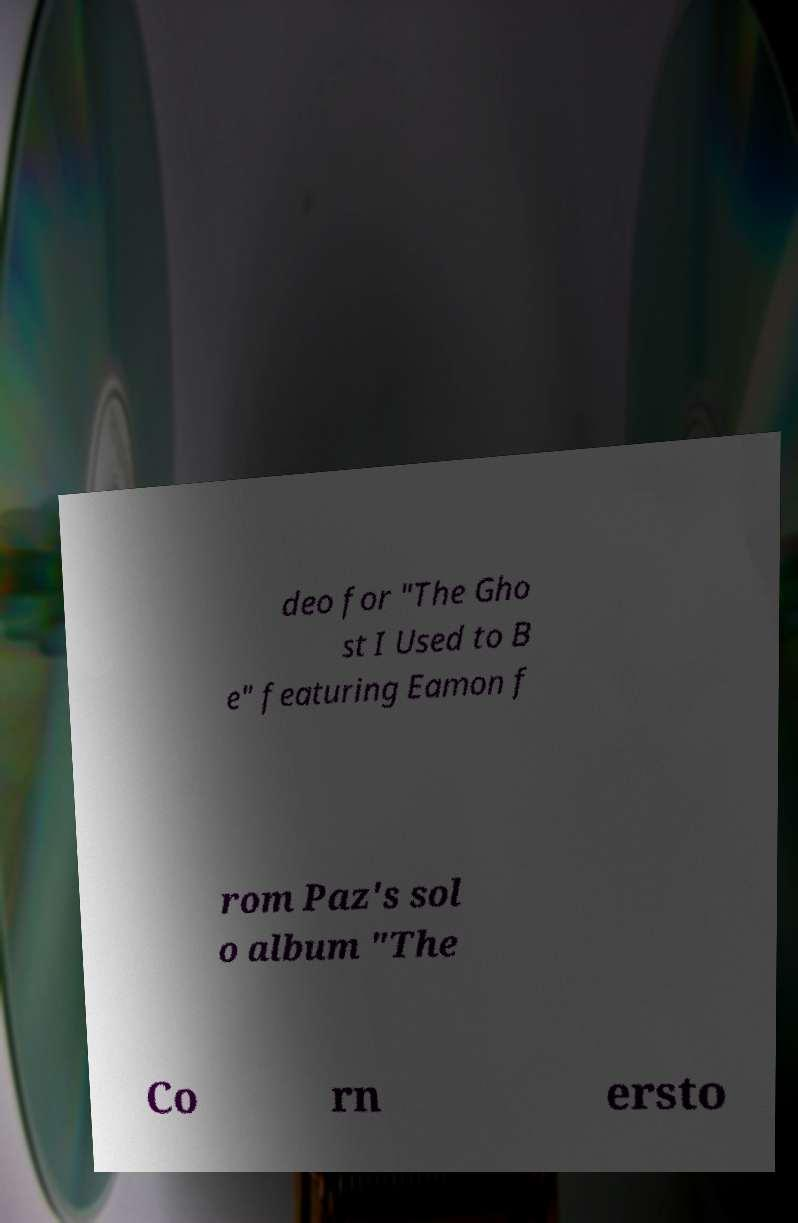Please read and relay the text visible in this image. What does it say? deo for "The Gho st I Used to B e" featuring Eamon f rom Paz's sol o album "The Co rn ersto 